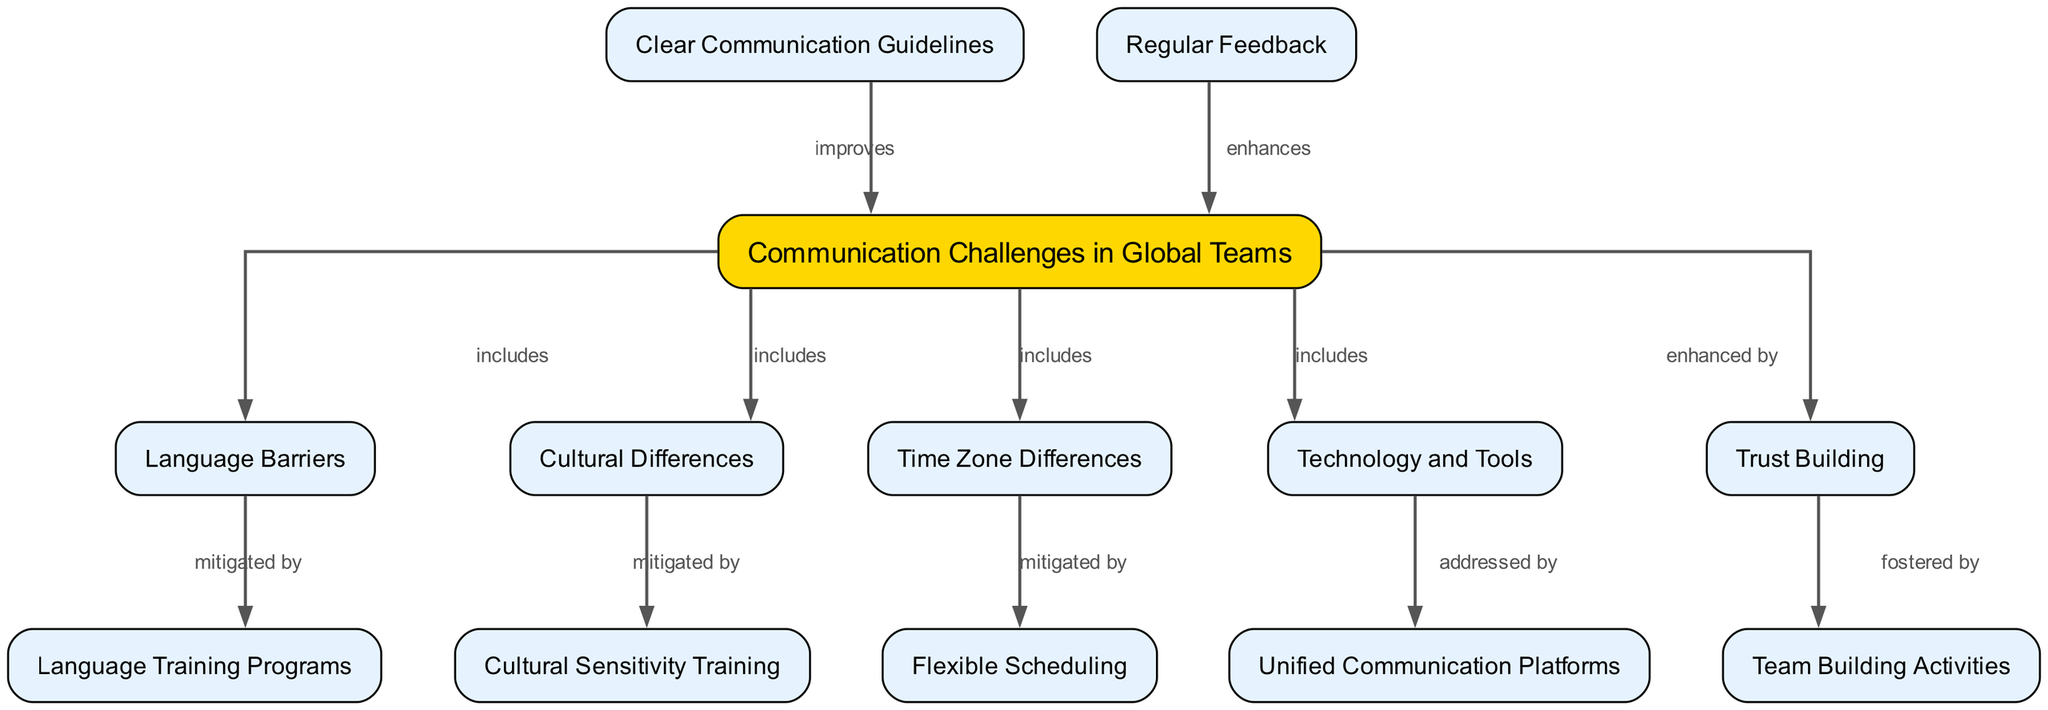What are the four main categories of communication challenges in global teams? The diagram has labeled the main challenges as "Language Barriers", "Cultural Differences", "Time Zone Differences", and "Technology and Tools". These are the four nodes directly related to the overarching node "Communication Challenges in Global Teams".
Answer: Language Barriers, Cultural Differences, Time Zone Differences, Technology and Tools Which node is enhanced by trust building? The diagram indicates that "Trust Building" enhances "Communication Challenges in Global Teams". To answer, we find the source of the enhancement relationship, which is "Trust Building" pointing to the main challenge node.
Answer: Communication Challenges in Global Teams How many nodes represent solutions or best practices in the diagram? Looking at the diagram, we count the nodes that represent solutions: "Clear Communication Guidelines", "Regular Feedback", "Cultural Sensitivity Training", "Flexible Scheduling", "Unified Communication Platforms", and "Team Building Activities". This gives us a total of six solution nodes connected in various ways.
Answer: 6 Which challenge is mitigated by language training programs? The diagram shows that "Language Barriers" is mitigated by the node "Language Training Programs". By tracing the connection from "Language Barriers", we see that it directly connects to "Language Training Programs" as a solution to address this challenge.
Answer: Language Barriers What is the relationship between clear communication guidelines and communication challenges? According to the diagram, "Clear Communication Guidelines" improve "Communication Challenges in Global Teams". The edge labeled "improves" shows this positive relationship, demonstrating that having clear guidelines helps alleviate the challenges.
Answer: improves 